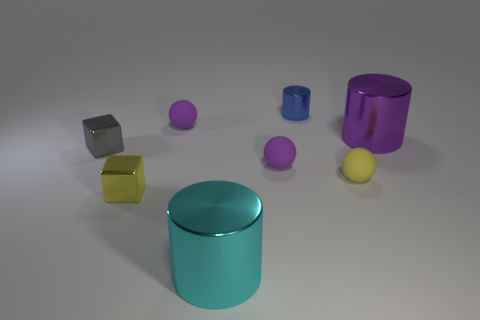There is a small cylinder that is made of the same material as the small yellow cube; what color is it?
Your answer should be compact. Blue. Do the yellow block and the large cylinder right of the cyan object have the same material?
Offer a very short reply. Yes. There is a small rubber object that is both in front of the gray shiny block and left of the yellow rubber thing; what color is it?
Your answer should be very brief. Purple. What number of cylinders are either gray metallic things or small yellow shiny objects?
Your answer should be very brief. 0. Does the yellow metal thing have the same shape as the small metallic object left of the yellow metallic cube?
Offer a very short reply. Yes. How big is the metal object that is on the left side of the big cyan cylinder and behind the yellow metal cube?
Your answer should be very brief. Small. The small gray object is what shape?
Keep it short and to the point. Cube. There is a object that is to the left of the yellow metal cube; are there any small purple balls that are on the left side of it?
Provide a short and direct response. No. What number of tiny blue metallic things are in front of the metal block behind the yellow block?
Give a very brief answer. 0. What is the material of the other cube that is the same size as the gray metallic cube?
Give a very brief answer. Metal. 